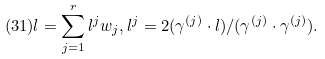<formula> <loc_0><loc_0><loc_500><loc_500>( 3 1 ) l = \sum _ { j = 1 } ^ { r } l ^ { j } w _ { j } , l ^ { j } = 2 ( \gamma ^ { ( j ) } \cdot l ) / ( \gamma ^ { ( j ) } \cdot \gamma ^ { ( j ) } ) .</formula> 